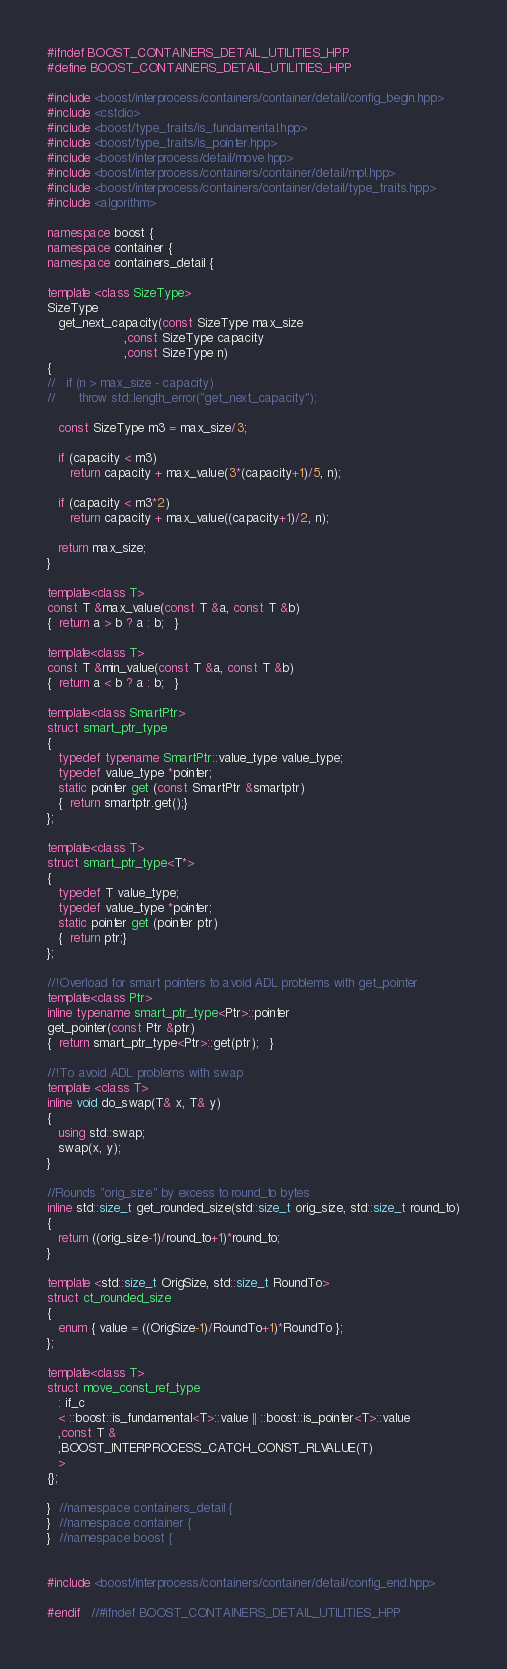Convert code to text. <code><loc_0><loc_0><loc_500><loc_500><_C++_>
#ifndef BOOST_CONTAINERS_DETAIL_UTILITIES_HPP
#define BOOST_CONTAINERS_DETAIL_UTILITIES_HPP

#include <boost/interprocess/containers/container/detail/config_begin.hpp>
#include <cstdio>
#include <boost/type_traits/is_fundamental.hpp>
#include <boost/type_traits/is_pointer.hpp>
#include <boost/interprocess/detail/move.hpp>
#include <boost/interprocess/containers/container/detail/mpl.hpp>
#include <boost/interprocess/containers/container/detail/type_traits.hpp>
#include <algorithm>

namespace boost {
namespace container {
namespace containers_detail {

template <class SizeType>
SizeType
   get_next_capacity(const SizeType max_size
                    ,const SizeType capacity
                    ,const SizeType n)
{
//   if (n > max_size - capacity)
//      throw std::length_error("get_next_capacity");

   const SizeType m3 = max_size/3;

   if (capacity < m3)
      return capacity + max_value(3*(capacity+1)/5, n);

   if (capacity < m3*2)
      return capacity + max_value((capacity+1)/2, n);

   return max_size;
}

template<class T>
const T &max_value(const T &a, const T &b)
{  return a > b ? a : b;   }

template<class T>
const T &min_value(const T &a, const T &b)
{  return a < b ? a : b;   }

template<class SmartPtr>
struct smart_ptr_type
{
   typedef typename SmartPtr::value_type value_type;
   typedef value_type *pointer;
   static pointer get (const SmartPtr &smartptr)
   {  return smartptr.get();}
};

template<class T>
struct smart_ptr_type<T*>
{
   typedef T value_type;
   typedef value_type *pointer;
   static pointer get (pointer ptr)
   {  return ptr;}
};

//!Overload for smart pointers to avoid ADL problems with get_pointer
template<class Ptr>
inline typename smart_ptr_type<Ptr>::pointer
get_pointer(const Ptr &ptr)
{  return smart_ptr_type<Ptr>::get(ptr);   }

//!To avoid ADL problems with swap
template <class T>
inline void do_swap(T& x, T& y)
{
   using std::swap;
   swap(x, y);
}

//Rounds "orig_size" by excess to round_to bytes
inline std::size_t get_rounded_size(std::size_t orig_size, std::size_t round_to)
{
   return ((orig_size-1)/round_to+1)*round_to;
}

template <std::size_t OrigSize, std::size_t RoundTo>
struct ct_rounded_size
{
   enum { value = ((OrigSize-1)/RoundTo+1)*RoundTo };
};

template<class T>
struct move_const_ref_type
   : if_c
   < ::boost::is_fundamental<T>::value || ::boost::is_pointer<T>::value
   ,const T &
   ,BOOST_INTERPROCESS_CATCH_CONST_RLVALUE(T)
   >
{};

}  //namespace containers_detail {
}  //namespace container {
}  //namespace boost {


#include <boost/interprocess/containers/container/detail/config_end.hpp>

#endif   //#ifndef BOOST_CONTAINERS_DETAIL_UTILITIES_HPP
</code> 